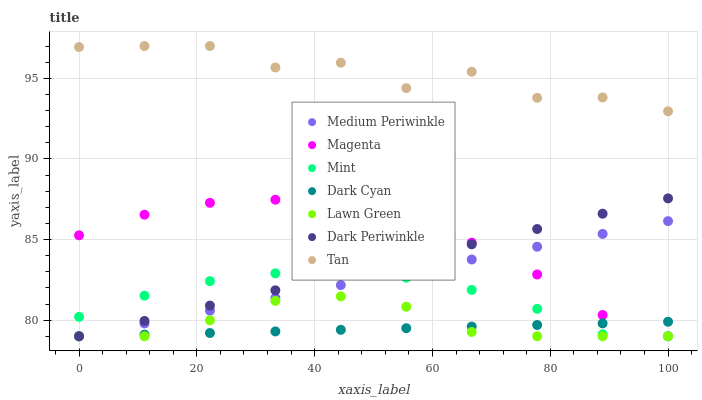Does Dark Cyan have the minimum area under the curve?
Answer yes or no. Yes. Does Tan have the maximum area under the curve?
Answer yes or no. Yes. Does Medium Periwinkle have the minimum area under the curve?
Answer yes or no. No. Does Medium Periwinkle have the maximum area under the curve?
Answer yes or no. No. Is Medium Periwinkle the smoothest?
Answer yes or no. Yes. Is Tan the roughest?
Answer yes or no. Yes. Is Tan the smoothest?
Answer yes or no. No. Is Medium Periwinkle the roughest?
Answer yes or no. No. Does Lawn Green have the lowest value?
Answer yes or no. Yes. Does Tan have the lowest value?
Answer yes or no. No. Does Tan have the highest value?
Answer yes or no. Yes. Does Medium Periwinkle have the highest value?
Answer yes or no. No. Is Dark Periwinkle less than Tan?
Answer yes or no. Yes. Is Tan greater than Mint?
Answer yes or no. Yes. Does Medium Periwinkle intersect Dark Periwinkle?
Answer yes or no. Yes. Is Medium Periwinkle less than Dark Periwinkle?
Answer yes or no. No. Is Medium Periwinkle greater than Dark Periwinkle?
Answer yes or no. No. Does Dark Periwinkle intersect Tan?
Answer yes or no. No. 